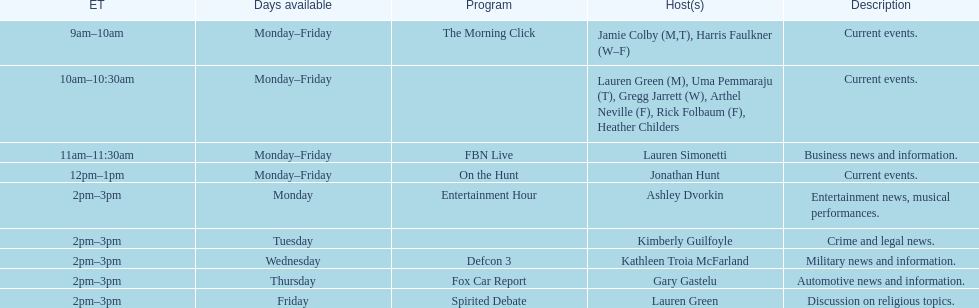What is the duration of on the hunt? 1 hour. 